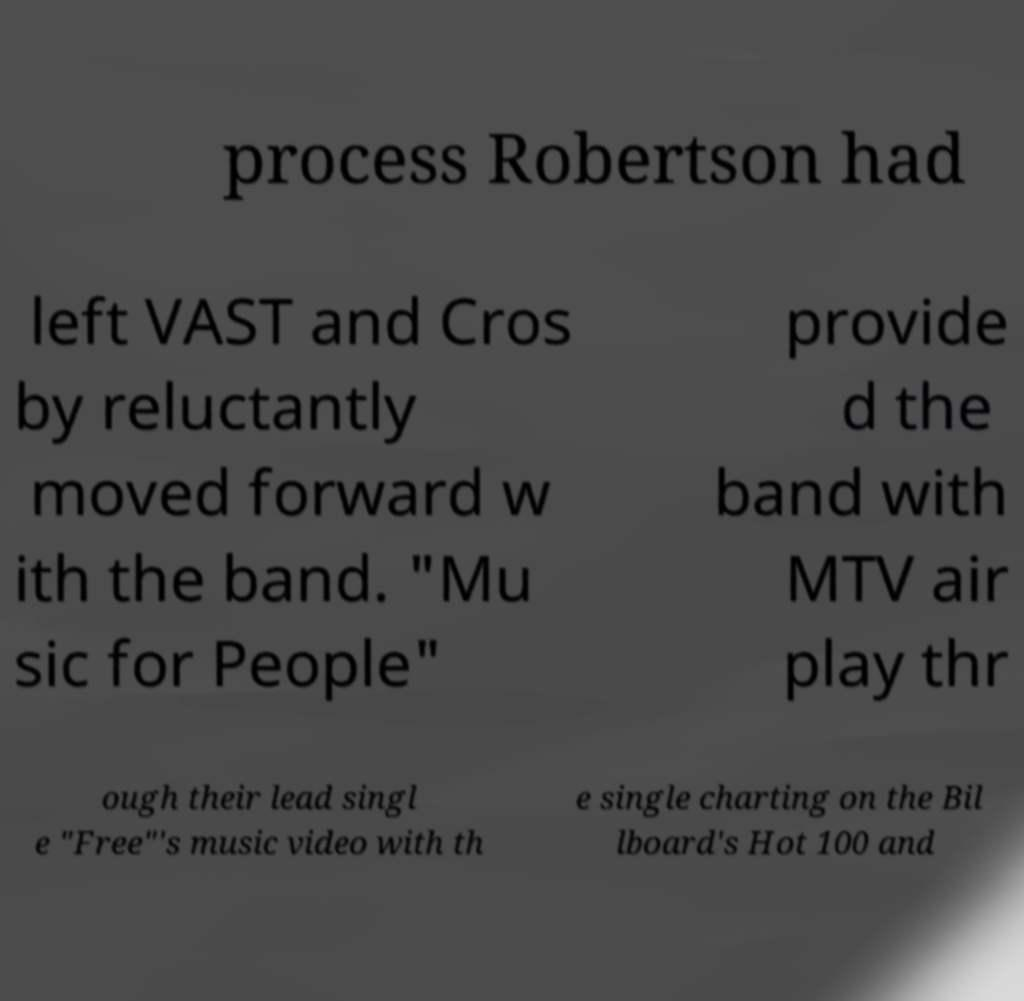Can you read and provide the text displayed in the image?This photo seems to have some interesting text. Can you extract and type it out for me? process Robertson had left VAST and Cros by reluctantly moved forward w ith the band. "Mu sic for People" provide d the band with MTV air play thr ough their lead singl e "Free"'s music video with th e single charting on the Bil lboard's Hot 100 and 